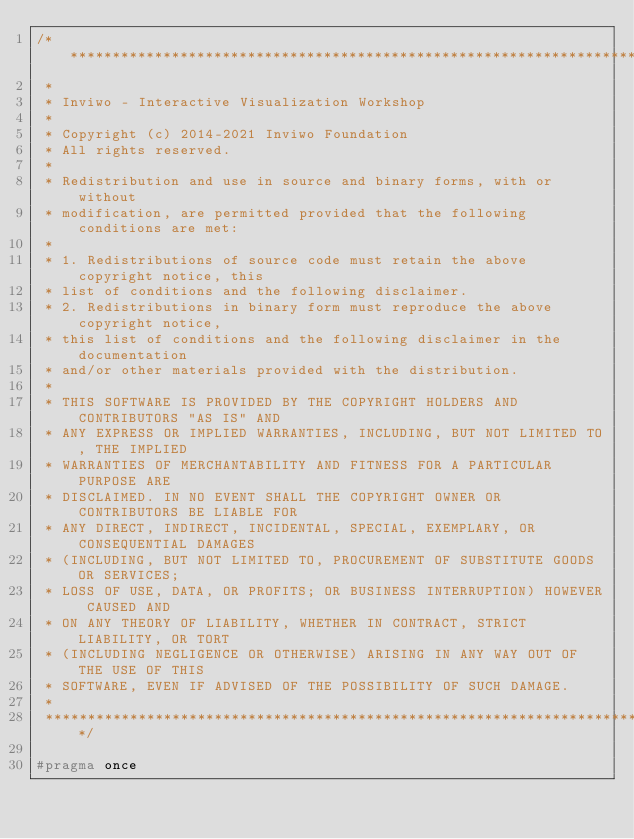<code> <loc_0><loc_0><loc_500><loc_500><_C_>/*********************************************************************************
 *
 * Inviwo - Interactive Visualization Workshop
 *
 * Copyright (c) 2014-2021 Inviwo Foundation
 * All rights reserved.
 *
 * Redistribution and use in source and binary forms, with or without
 * modification, are permitted provided that the following conditions are met:
 *
 * 1. Redistributions of source code must retain the above copyright notice, this
 * list of conditions and the following disclaimer.
 * 2. Redistributions in binary form must reproduce the above copyright notice,
 * this list of conditions and the following disclaimer in the documentation
 * and/or other materials provided with the distribution.
 *
 * THIS SOFTWARE IS PROVIDED BY THE COPYRIGHT HOLDERS AND CONTRIBUTORS "AS IS" AND
 * ANY EXPRESS OR IMPLIED WARRANTIES, INCLUDING, BUT NOT LIMITED TO, THE IMPLIED
 * WARRANTIES OF MERCHANTABILITY AND FITNESS FOR A PARTICULAR PURPOSE ARE
 * DISCLAIMED. IN NO EVENT SHALL THE COPYRIGHT OWNER OR CONTRIBUTORS BE LIABLE FOR
 * ANY DIRECT, INDIRECT, INCIDENTAL, SPECIAL, EXEMPLARY, OR CONSEQUENTIAL DAMAGES
 * (INCLUDING, BUT NOT LIMITED TO, PROCUREMENT OF SUBSTITUTE GOODS OR SERVICES;
 * LOSS OF USE, DATA, OR PROFITS; OR BUSINESS INTERRUPTION) HOWEVER CAUSED AND
 * ON ANY THEORY OF LIABILITY, WHETHER IN CONTRACT, STRICT LIABILITY, OR TORT
 * (INCLUDING NEGLIGENCE OR OTHERWISE) ARISING IN ANY WAY OUT OF THE USE OF THIS
 * SOFTWARE, EVEN IF ADVISED OF THE POSSIBILITY OF SUCH DAMAGE.
 *
 *********************************************************************************/

#pragma once
</code> 